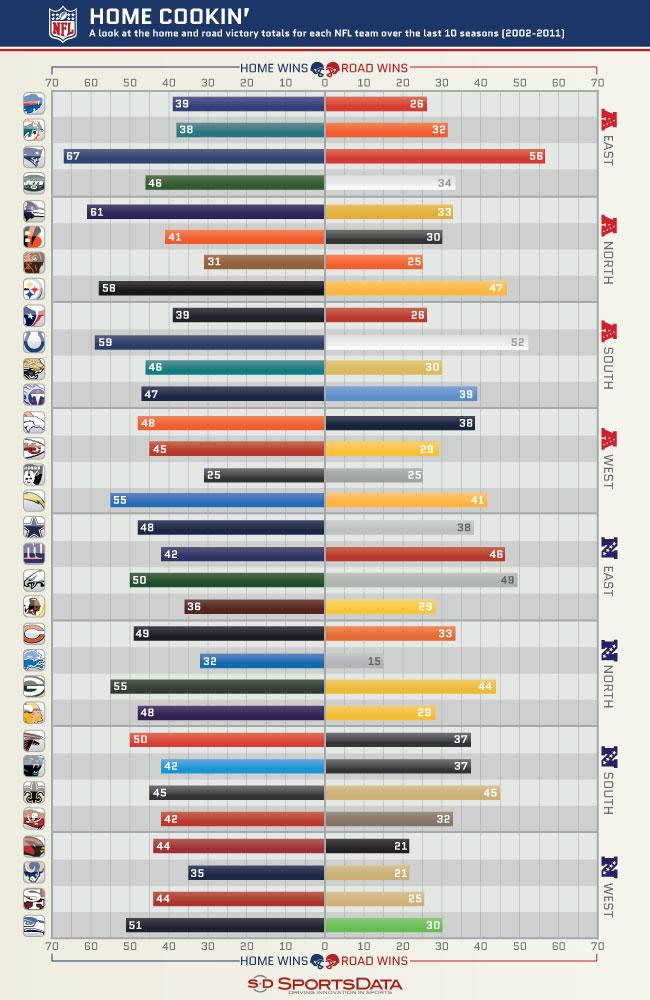Outline some significant characteristics in this image. The National Football Conference has recorded the highest number of road wins among its teams from the North, South, East, and West. Specifically, the conference has a total of 49 road wins, the highest among all four regions. The New England Patriots have scored the highest number of home wins among all teams in the American football conference, which is located in the north, south, east, and west. The Green Bay Packers have won 44 road games and 55 home games in the NFC, making them the team with the most victories in both categories. The NFC West has won only 21 road games, which is the least number of road wins by any division in the NFL. 